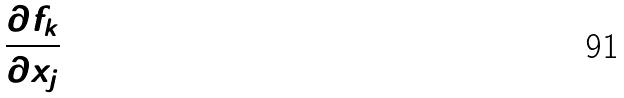<formula> <loc_0><loc_0><loc_500><loc_500>\frac { \partial f _ { k } } { \partial x _ { j } }</formula> 